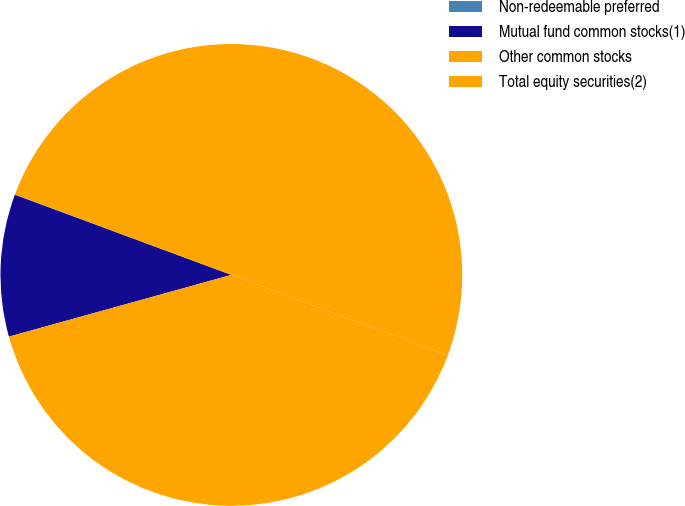<chart> <loc_0><loc_0><loc_500><loc_500><pie_chart><fcel>Non-redeemable preferred<fcel>Mutual fund common stocks(1)<fcel>Other common stocks<fcel>Total equity securities(2)<nl><fcel>0.03%<fcel>9.95%<fcel>40.02%<fcel>50.0%<nl></chart> 